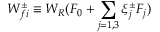<formula> <loc_0><loc_0><loc_500><loc_500>W _ { f i } ^ { \pm } \equiv W _ { R } ( F _ { 0 } + \sum _ { j = 1 , 3 } \xi _ { j } ^ { \pm } F _ { j } )</formula> 